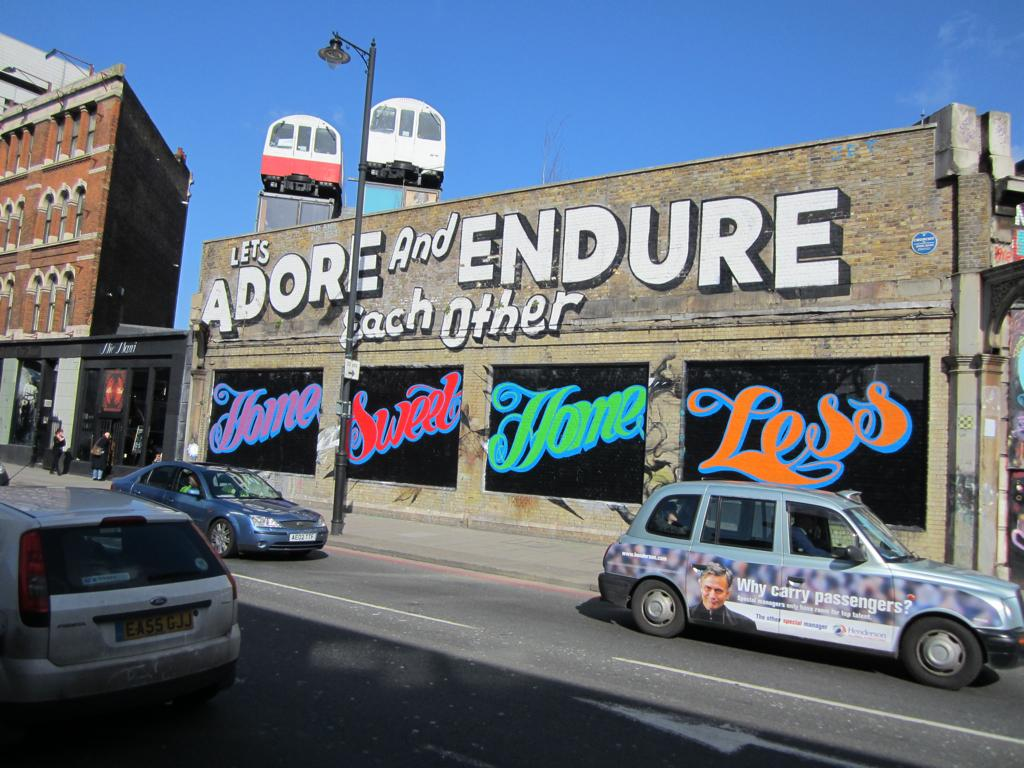<image>
Present a compact description of the photo's key features. A building with cars parked outside says Lets Adore and Endure Each Other in big white letters. 